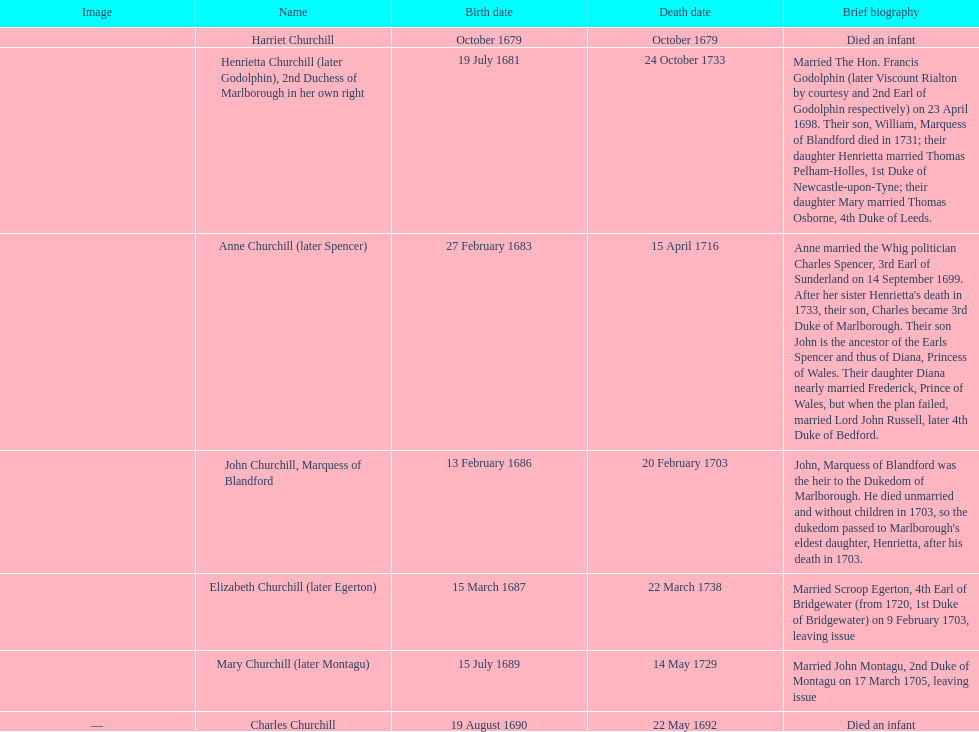How many children were born in february? 2. 